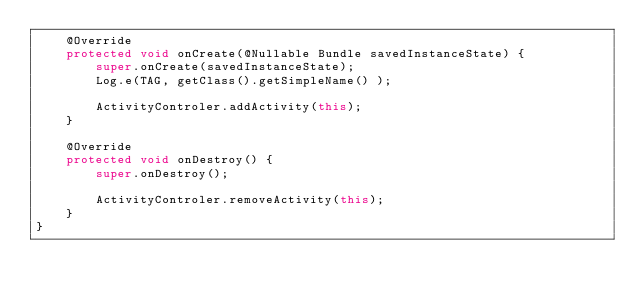Convert code to text. <code><loc_0><loc_0><loc_500><loc_500><_Java_>    @Override
    protected void onCreate(@Nullable Bundle savedInstanceState) {
        super.onCreate(savedInstanceState);
        Log.e(TAG, getClass().getSimpleName() );

        ActivityControler.addActivity(this);
    }

    @Override
    protected void onDestroy() {
        super.onDestroy();

        ActivityControler.removeActivity(this);
    }
}
</code> 